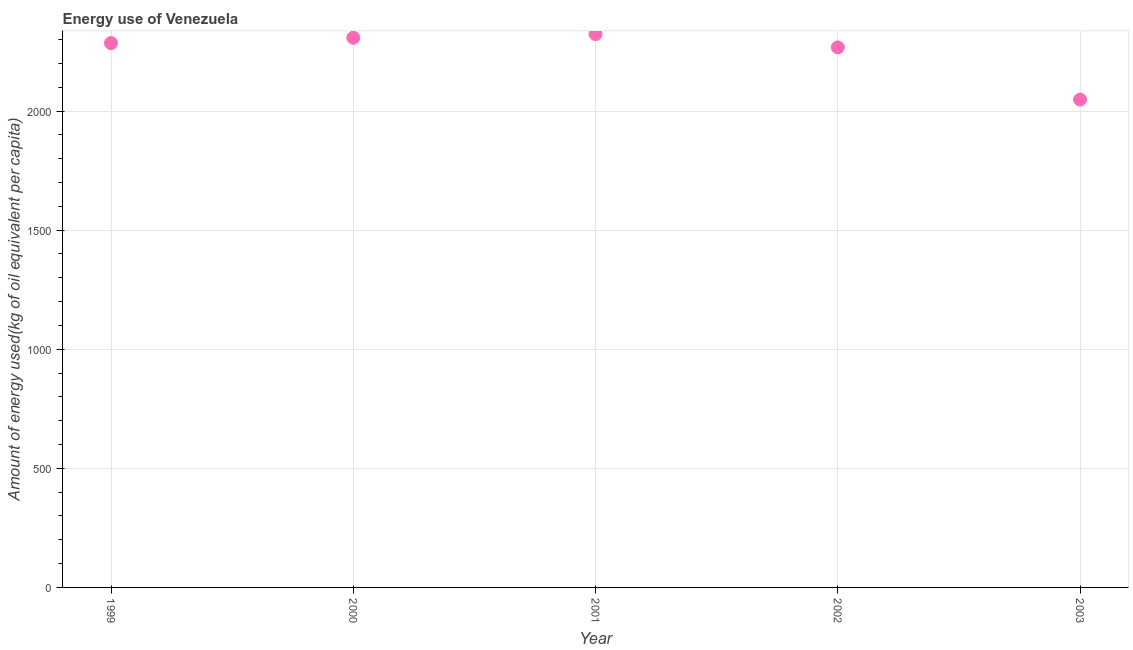What is the amount of energy used in 1999?
Give a very brief answer. 2285.26. Across all years, what is the maximum amount of energy used?
Offer a very short reply. 2323.1. Across all years, what is the minimum amount of energy used?
Ensure brevity in your answer.  2048.14. What is the sum of the amount of energy used?
Keep it short and to the point. 1.12e+04. What is the difference between the amount of energy used in 2000 and 2001?
Your answer should be compact. -15.4. What is the average amount of energy used per year?
Your answer should be very brief. 2246.31. What is the median amount of energy used?
Ensure brevity in your answer.  2285.26. What is the ratio of the amount of energy used in 2001 to that in 2003?
Keep it short and to the point. 1.13. Is the difference between the amount of energy used in 2001 and 2003 greater than the difference between any two years?
Keep it short and to the point. Yes. What is the difference between the highest and the second highest amount of energy used?
Offer a very short reply. 15.4. What is the difference between the highest and the lowest amount of energy used?
Provide a succinct answer. 274.96. In how many years, is the amount of energy used greater than the average amount of energy used taken over all years?
Provide a short and direct response. 4. How many dotlines are there?
Offer a very short reply. 1. How many years are there in the graph?
Your response must be concise. 5. What is the difference between two consecutive major ticks on the Y-axis?
Provide a short and direct response. 500. Are the values on the major ticks of Y-axis written in scientific E-notation?
Your answer should be compact. No. Does the graph contain any zero values?
Give a very brief answer. No. Does the graph contain grids?
Your answer should be compact. Yes. What is the title of the graph?
Keep it short and to the point. Energy use of Venezuela. What is the label or title of the X-axis?
Your answer should be compact. Year. What is the label or title of the Y-axis?
Provide a short and direct response. Amount of energy used(kg of oil equivalent per capita). What is the Amount of energy used(kg of oil equivalent per capita) in 1999?
Provide a short and direct response. 2285.26. What is the Amount of energy used(kg of oil equivalent per capita) in 2000?
Make the answer very short. 2307.71. What is the Amount of energy used(kg of oil equivalent per capita) in 2001?
Your answer should be compact. 2323.1. What is the Amount of energy used(kg of oil equivalent per capita) in 2002?
Offer a terse response. 2267.37. What is the Amount of energy used(kg of oil equivalent per capita) in 2003?
Your answer should be very brief. 2048.14. What is the difference between the Amount of energy used(kg of oil equivalent per capita) in 1999 and 2000?
Keep it short and to the point. -22.45. What is the difference between the Amount of energy used(kg of oil equivalent per capita) in 1999 and 2001?
Your answer should be compact. -37.85. What is the difference between the Amount of energy used(kg of oil equivalent per capita) in 1999 and 2002?
Provide a short and direct response. 17.89. What is the difference between the Amount of energy used(kg of oil equivalent per capita) in 1999 and 2003?
Provide a short and direct response. 237.12. What is the difference between the Amount of energy used(kg of oil equivalent per capita) in 2000 and 2001?
Ensure brevity in your answer.  -15.4. What is the difference between the Amount of energy used(kg of oil equivalent per capita) in 2000 and 2002?
Offer a terse response. 40.34. What is the difference between the Amount of energy used(kg of oil equivalent per capita) in 2000 and 2003?
Your answer should be compact. 259.56. What is the difference between the Amount of energy used(kg of oil equivalent per capita) in 2001 and 2002?
Provide a short and direct response. 55.73. What is the difference between the Amount of energy used(kg of oil equivalent per capita) in 2001 and 2003?
Ensure brevity in your answer.  274.96. What is the difference between the Amount of energy used(kg of oil equivalent per capita) in 2002 and 2003?
Make the answer very short. 219.23. What is the ratio of the Amount of energy used(kg of oil equivalent per capita) in 1999 to that in 2003?
Offer a terse response. 1.12. What is the ratio of the Amount of energy used(kg of oil equivalent per capita) in 2000 to that in 2001?
Provide a short and direct response. 0.99. What is the ratio of the Amount of energy used(kg of oil equivalent per capita) in 2000 to that in 2002?
Ensure brevity in your answer.  1.02. What is the ratio of the Amount of energy used(kg of oil equivalent per capita) in 2000 to that in 2003?
Offer a terse response. 1.13. What is the ratio of the Amount of energy used(kg of oil equivalent per capita) in 2001 to that in 2002?
Offer a terse response. 1.02. What is the ratio of the Amount of energy used(kg of oil equivalent per capita) in 2001 to that in 2003?
Ensure brevity in your answer.  1.13. What is the ratio of the Amount of energy used(kg of oil equivalent per capita) in 2002 to that in 2003?
Offer a very short reply. 1.11. 